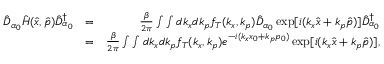Convert formula to latex. <formula><loc_0><loc_0><loc_500><loc_500>\begin{array} { r l r } { \hat { D } _ { \alpha _ { 0 } } \hat { H } ( \hat { x } , \hat { p } ) \hat { D } _ { \alpha _ { 0 } } ^ { \dagger } } & { = } & { \frac { \beta } { 2 \pi } \int \int d k _ { x } d k _ { p } f _ { T } ( k _ { x } , k _ { p } ) \hat { D } _ { \alpha _ { 0 } } \exp [ i ( k _ { x } \hat { x } + k _ { p } \hat { p } ) ] \hat { D } _ { \alpha _ { 0 } } ^ { \dagger } } \\ & { = } & { \frac { \beta } { 2 \pi } \int \int d k _ { x } d k _ { p } f _ { T } ( k _ { x } , k _ { p } ) e ^ { - i ( k _ { x } x _ { 0 } + k _ { p } p _ { 0 } ) } \exp [ i ( k _ { x } \hat { x } + k _ { p } \hat { p } ) ] , } \end{array}</formula> 